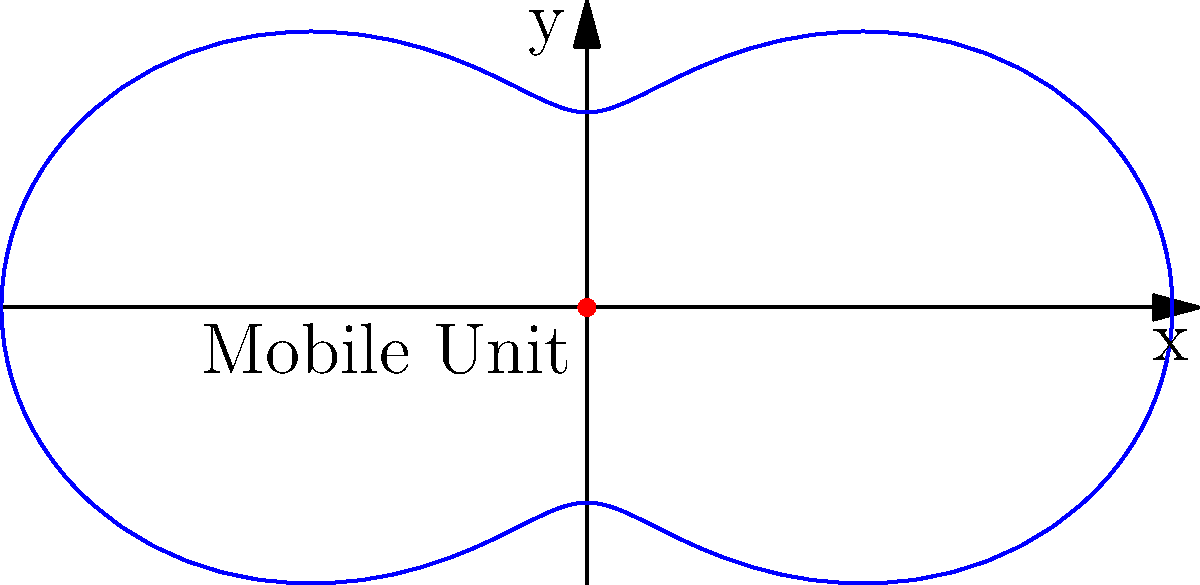A mobile pastry distribution unit covers an area represented by the polar equation $r = 2 + \cos(2\theta)$. What is the maximum distance the unit can reach from its central location? To find the maximum distance the mobile unit can reach, we need to determine the maximum value of $r$ in the given polar equation.

Step 1: Analyze the equation $r = 2 + \cos(2\theta)$
- The constant term is 2
- The cosine term oscillates between -1 and 1

Step 2: Find the maximum possible value
- The maximum value of $\cos(2\theta)$ is 1
- Therefore, the maximum value of $r$ occurs when $\cos(2\theta) = 1$
- $r_{max} = 2 + 1 = 3$

Step 3: Interpret the result
- The maximum distance the unit can reach is 3 units from its central location

This maximum occurs when $\theta = 0, \pi, 2\pi$, etc., which correspond to the outermost points of the shape in the positive x-direction.
Answer: 3 units 